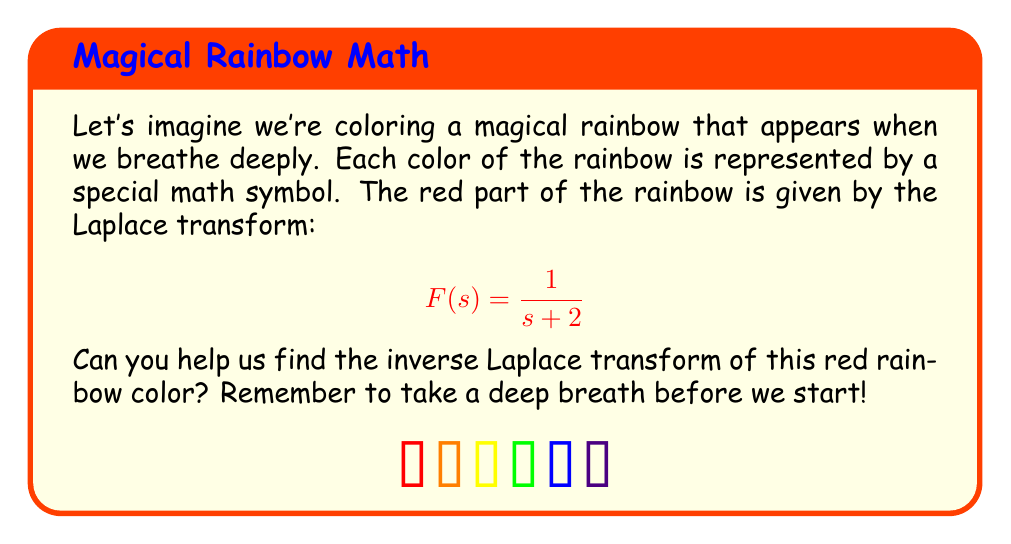Help me with this question. Let's approach this step-by-step, taking deep breaths as we go:

1) First, we recognize that this is a simple fraction in the form:

   $$F(s) = \frac{1}{s+a}$$

   where $a = 2$ in our case.

2) We know from the Laplace transform table that the inverse Laplace transform of this form is:

   $$\mathcal{L}^{-1}\left\{\frac{1}{s+a}\right\} = e^{-at}$$

3) In our rainbow problem, we substitute $a = 2$:

   $$\mathcal{L}^{-1}\left\{\frac{1}{s+2}\right\} = e^{-2t}$$

4) So, our red rainbow color in the time domain is represented by $e^{-2t}$.

Take another deep breath. Can you imagine this function as a gently fading red color in our rainbow?
Answer: $f(t) = e^{-2t}$ 